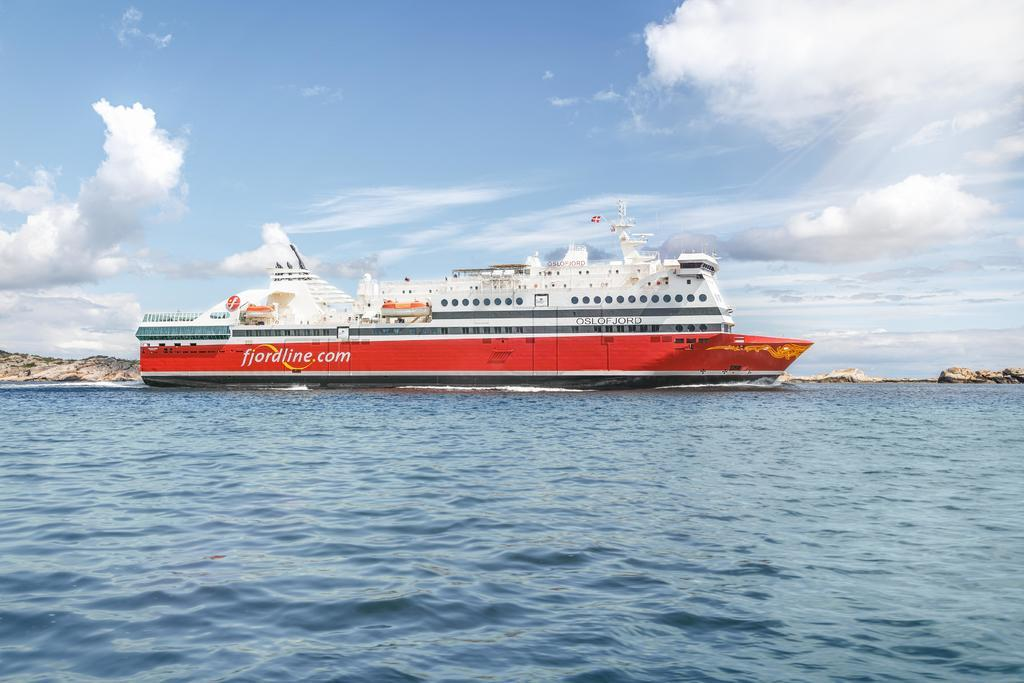What is the main subject in the center of the image? There is a ship in the center of the image. Where is the ship located? The ship is on the sea. What can be seen in the background of the image? There are hills and the sky visible in the background of the image. What type of blood is visible on the ship in the image? There is no blood visible on the ship in the image. What type of coal can be seen being transported by the ship in the image? There is no coal present in the image; the ship is on the sea with no visible cargo. 